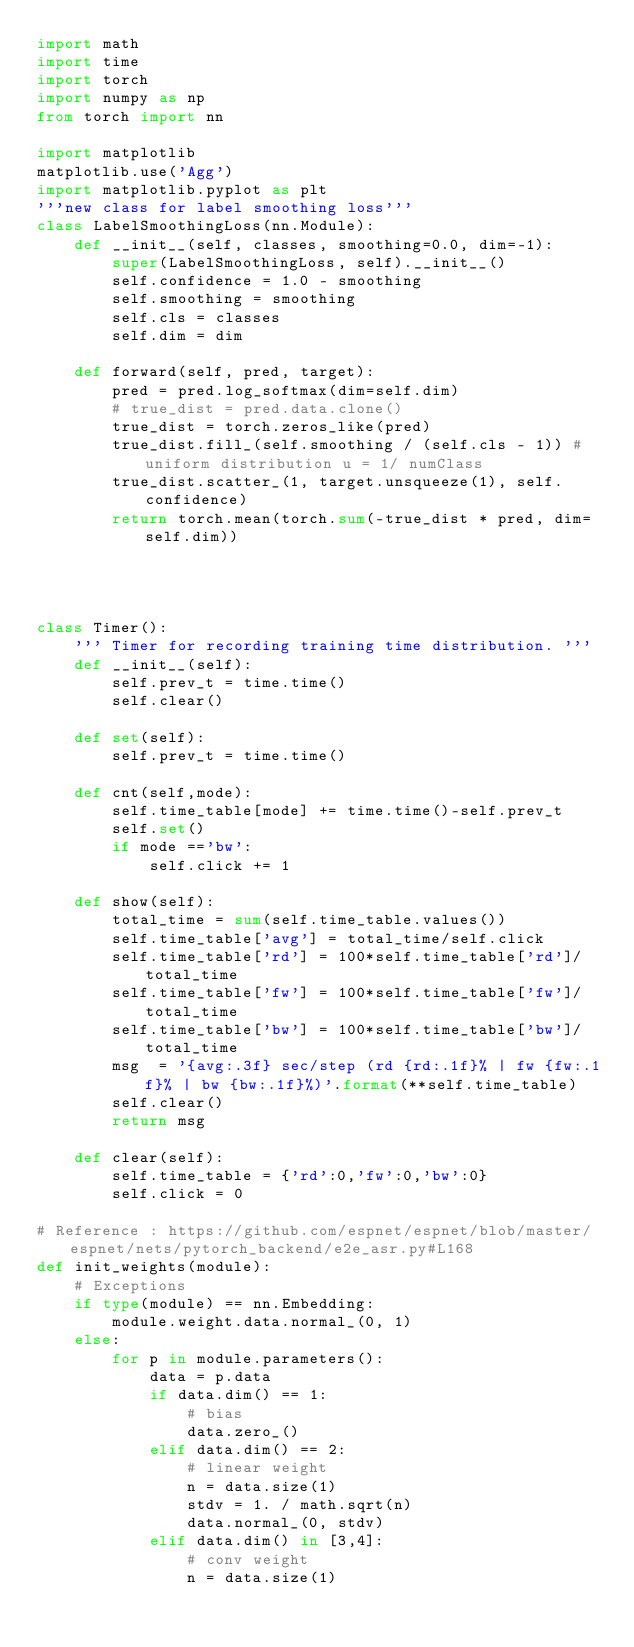Convert code to text. <code><loc_0><loc_0><loc_500><loc_500><_Python_>import math
import time
import torch
import numpy as np
from torch import nn

import matplotlib
matplotlib.use('Agg')
import matplotlib.pyplot as plt
'''new class for label smoothing loss'''
class LabelSmoothingLoss(nn.Module):
    def __init__(self, classes, smoothing=0.0, dim=-1):
        super(LabelSmoothingLoss, self).__init__()
        self.confidence = 1.0 - smoothing
        self.smoothing = smoothing
        self.cls = classes
        self.dim = dim

    def forward(self, pred, target):
        pred = pred.log_softmax(dim=self.dim)
        # true_dist = pred.data.clone()
        true_dist = torch.zeros_like(pred)
        true_dist.fill_(self.smoothing / (self.cls - 1)) # uniform distribution u = 1/ numClass
        true_dist.scatter_(1, target.unsqueeze(1), self.confidence)
        return torch.mean(torch.sum(-true_dist * pred, dim=self.dim))




class Timer():
    ''' Timer for recording training time distribution. '''
    def __init__(self):
        self.prev_t = time.time()
        self.clear()

    def set(self):
        self.prev_t = time.time()

    def cnt(self,mode):
        self.time_table[mode] += time.time()-self.prev_t
        self.set()
        if mode =='bw':
            self.click += 1

    def show(self):
        total_time = sum(self.time_table.values())
        self.time_table['avg'] = total_time/self.click
        self.time_table['rd'] = 100*self.time_table['rd']/total_time
        self.time_table['fw'] = 100*self.time_table['fw']/total_time
        self.time_table['bw'] = 100*self.time_table['bw']/total_time
        msg  = '{avg:.3f} sec/step (rd {rd:.1f}% | fw {fw:.1f}% | bw {bw:.1f}%)'.format(**self.time_table)
        self.clear()
        return msg

    def clear(self):
        self.time_table = {'rd':0,'fw':0,'bw':0}
        self.click = 0

# Reference : https://github.com/espnet/espnet/blob/master/espnet/nets/pytorch_backend/e2e_asr.py#L168
def init_weights(module):
    # Exceptions
    if type(module) == nn.Embedding:
        module.weight.data.normal_(0, 1)
    else:
        for p in module.parameters():
            data = p.data
            if data.dim() == 1:
                # bias
                data.zero_()
            elif data.dim() == 2:
                # linear weight
                n = data.size(1)
                stdv = 1. / math.sqrt(n)
                data.normal_(0, stdv)
            elif data.dim() in [3,4]:
                # conv weight
                n = data.size(1)</code> 